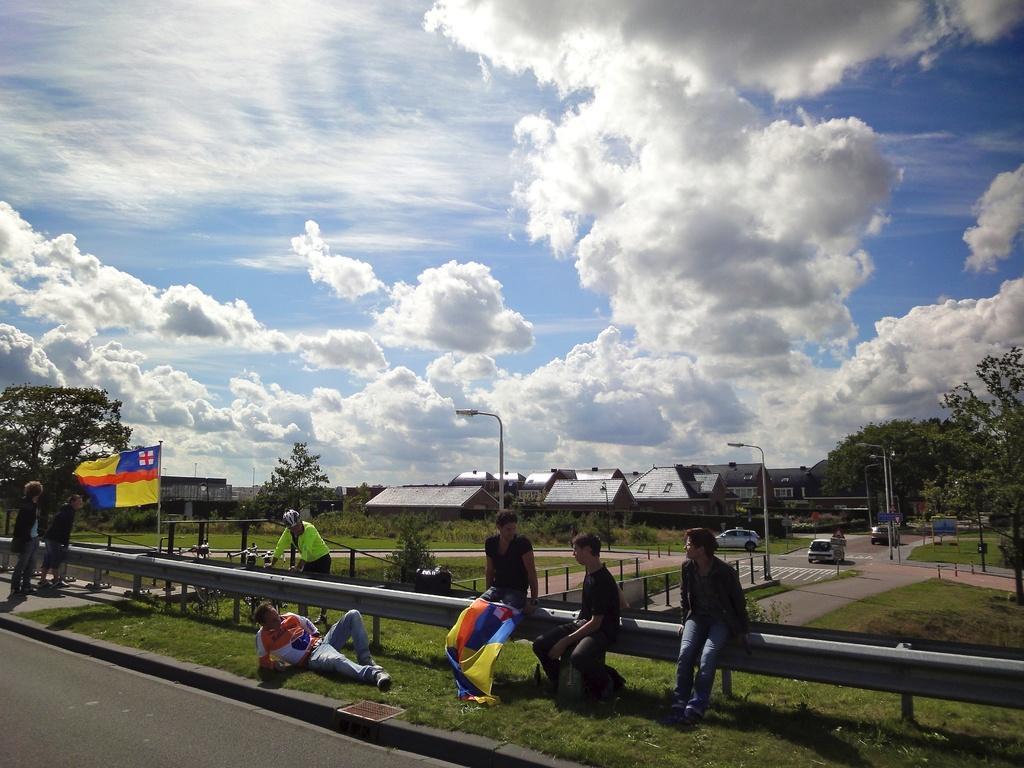Can you describe this image briefly? In the front of the image I can see people, flags, bicycles, railing, road and grass. Among them three people are sitting and three people are standing. In the background of the image I can see rods, light poles, signboards, houses, plants, trees, vehicles, cloudy sky and objects. 